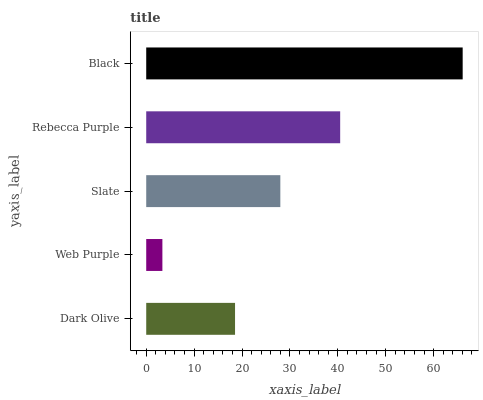Is Web Purple the minimum?
Answer yes or no. Yes. Is Black the maximum?
Answer yes or no. Yes. Is Slate the minimum?
Answer yes or no. No. Is Slate the maximum?
Answer yes or no. No. Is Slate greater than Web Purple?
Answer yes or no. Yes. Is Web Purple less than Slate?
Answer yes or no. Yes. Is Web Purple greater than Slate?
Answer yes or no. No. Is Slate less than Web Purple?
Answer yes or no. No. Is Slate the high median?
Answer yes or no. Yes. Is Slate the low median?
Answer yes or no. Yes. Is Black the high median?
Answer yes or no. No. Is Web Purple the low median?
Answer yes or no. No. 